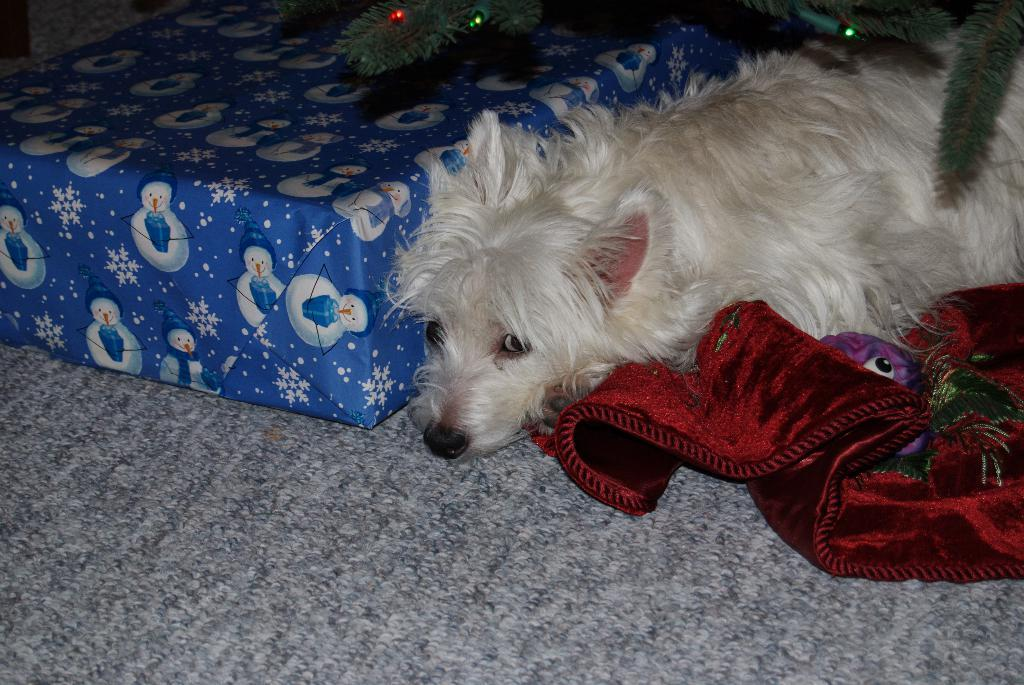What type of animal is in the image? There is a dog in the image. What is the dog doing in the image? The dog is lying on a mat. What can be seen on the right side of the image? There is a cloth on the right side of the image. What is located on the left side of the image? There is a gift pack on the left side of the image. How is the gift pack positioned in relation to the dog? The gift pack is beside the dog. What is on top of the gift pack? There are lights on top of the gift pack. What type of salt is sprinkled on the dog in the image? There is no salt present in the image; it features a dog lying on a mat with a gift pack beside it. 